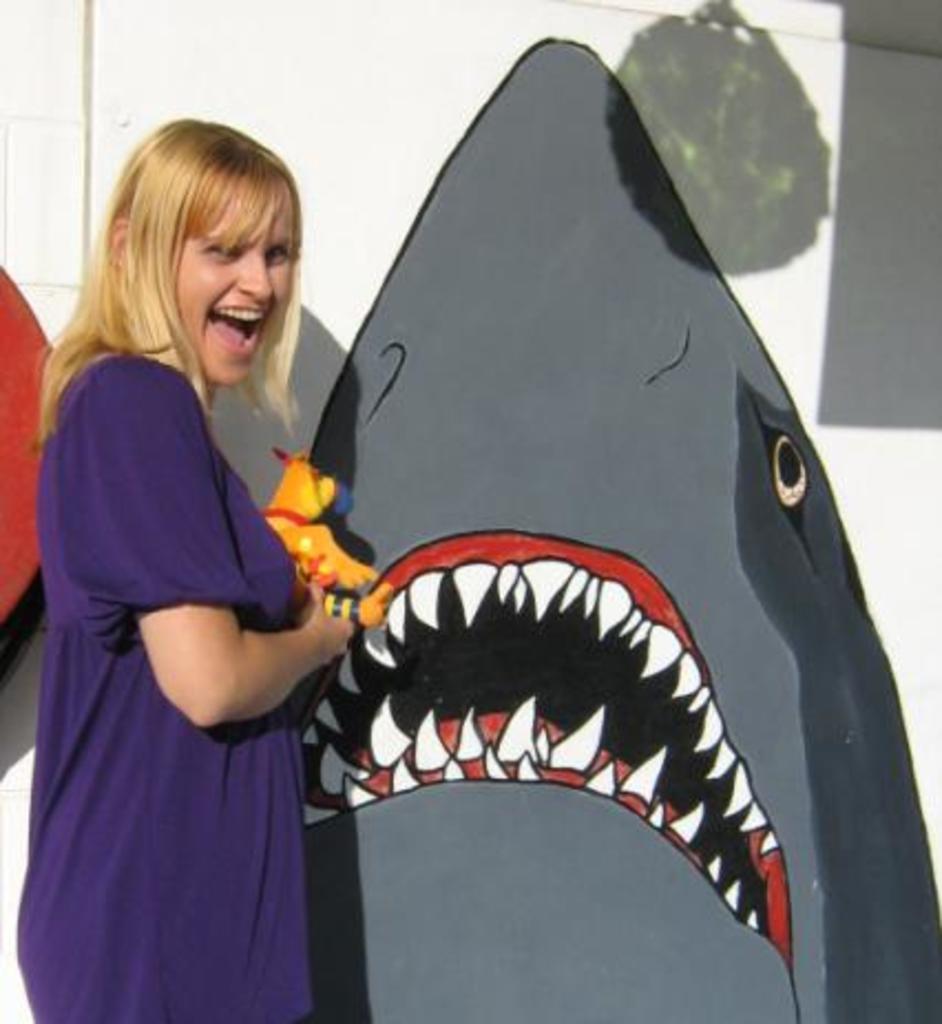How would you summarize this image in a sentence or two? In this picture I can see there is a woman standing here and she is wearing a violet shirt and holding a object and smiling. In the backdrop there is a wall with a shark painting and it has sharp teeth and it is in grey color. 